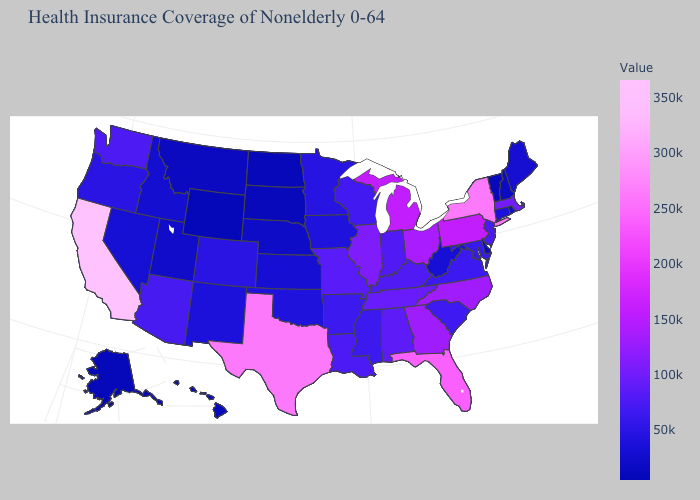Among the states that border Tennessee , which have the lowest value?
Give a very brief answer. Arkansas. Which states have the lowest value in the USA?
Give a very brief answer. Wyoming. Among the states that border Oregon , which have the highest value?
Give a very brief answer. California. Is the legend a continuous bar?
Write a very short answer. Yes. 